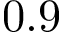<formula> <loc_0><loc_0><loc_500><loc_500>0 . 9</formula> 